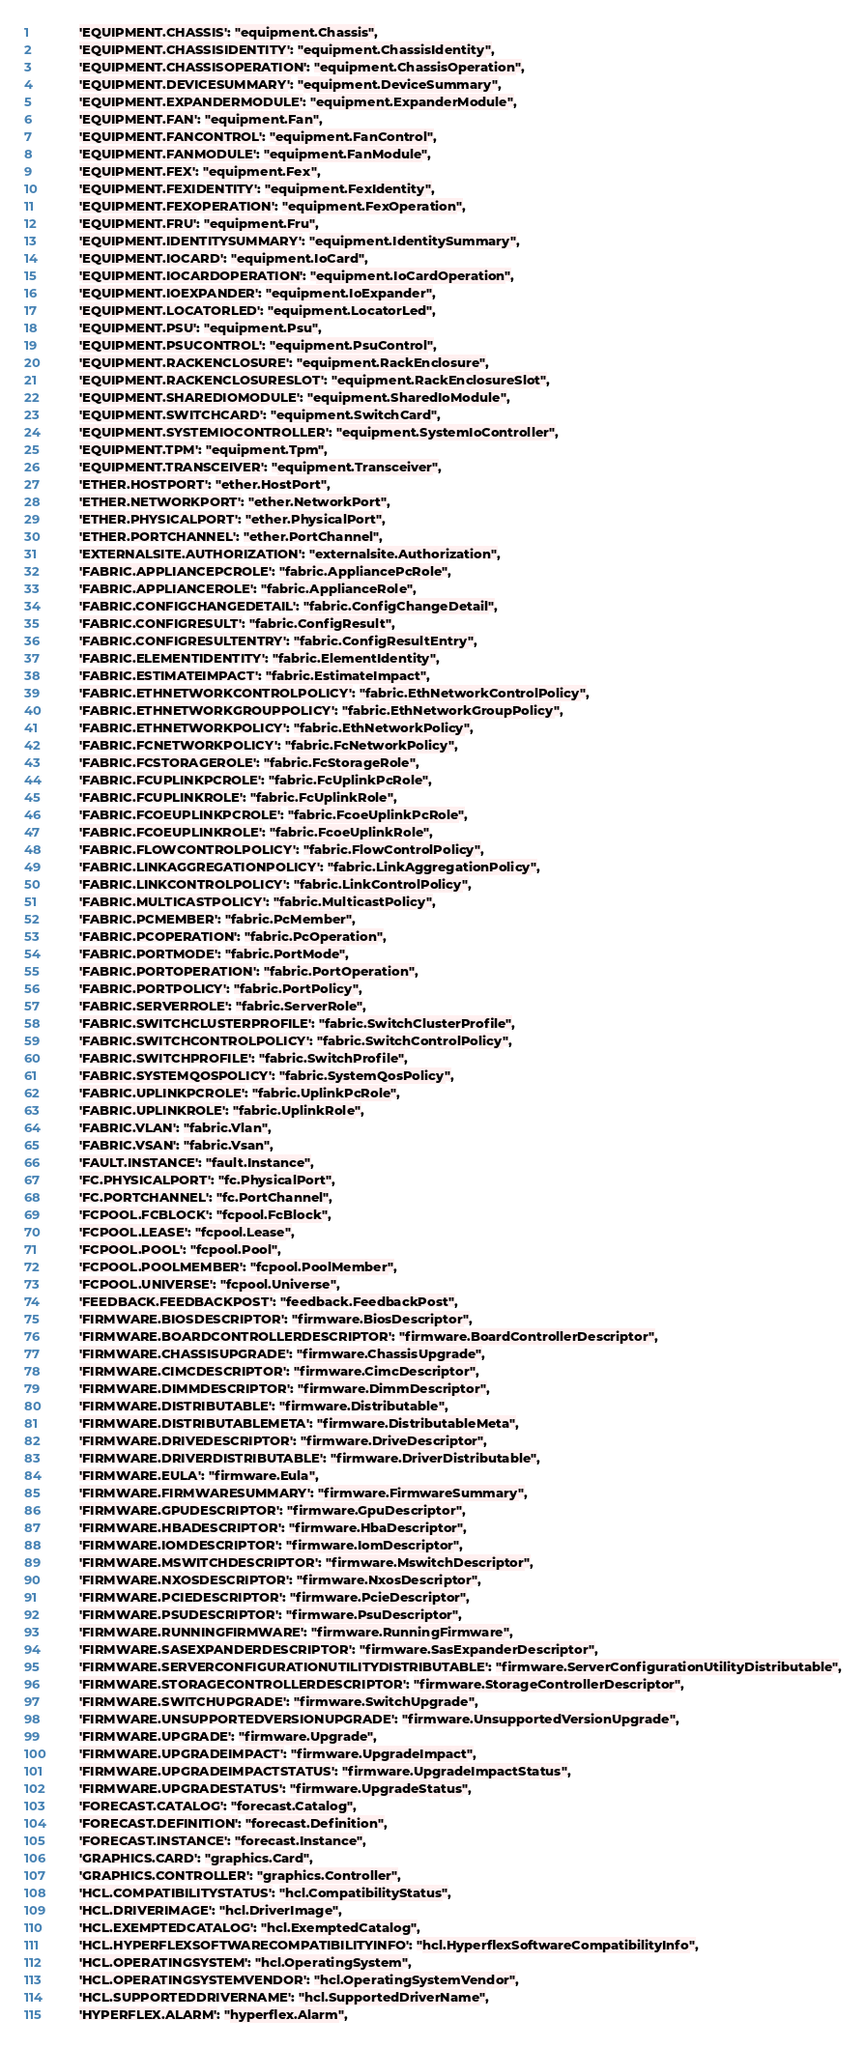Convert code to text. <code><loc_0><loc_0><loc_500><loc_500><_Python_>            'EQUIPMENT.CHASSIS': "equipment.Chassis",
            'EQUIPMENT.CHASSISIDENTITY': "equipment.ChassisIdentity",
            'EQUIPMENT.CHASSISOPERATION': "equipment.ChassisOperation",
            'EQUIPMENT.DEVICESUMMARY': "equipment.DeviceSummary",
            'EQUIPMENT.EXPANDERMODULE': "equipment.ExpanderModule",
            'EQUIPMENT.FAN': "equipment.Fan",
            'EQUIPMENT.FANCONTROL': "equipment.FanControl",
            'EQUIPMENT.FANMODULE': "equipment.FanModule",
            'EQUIPMENT.FEX': "equipment.Fex",
            'EQUIPMENT.FEXIDENTITY': "equipment.FexIdentity",
            'EQUIPMENT.FEXOPERATION': "equipment.FexOperation",
            'EQUIPMENT.FRU': "equipment.Fru",
            'EQUIPMENT.IDENTITYSUMMARY': "equipment.IdentitySummary",
            'EQUIPMENT.IOCARD': "equipment.IoCard",
            'EQUIPMENT.IOCARDOPERATION': "equipment.IoCardOperation",
            'EQUIPMENT.IOEXPANDER': "equipment.IoExpander",
            'EQUIPMENT.LOCATORLED': "equipment.LocatorLed",
            'EQUIPMENT.PSU': "equipment.Psu",
            'EQUIPMENT.PSUCONTROL': "equipment.PsuControl",
            'EQUIPMENT.RACKENCLOSURE': "equipment.RackEnclosure",
            'EQUIPMENT.RACKENCLOSURESLOT': "equipment.RackEnclosureSlot",
            'EQUIPMENT.SHAREDIOMODULE': "equipment.SharedIoModule",
            'EQUIPMENT.SWITCHCARD': "equipment.SwitchCard",
            'EQUIPMENT.SYSTEMIOCONTROLLER': "equipment.SystemIoController",
            'EQUIPMENT.TPM': "equipment.Tpm",
            'EQUIPMENT.TRANSCEIVER': "equipment.Transceiver",
            'ETHER.HOSTPORT': "ether.HostPort",
            'ETHER.NETWORKPORT': "ether.NetworkPort",
            'ETHER.PHYSICALPORT': "ether.PhysicalPort",
            'ETHER.PORTCHANNEL': "ether.PortChannel",
            'EXTERNALSITE.AUTHORIZATION': "externalsite.Authorization",
            'FABRIC.APPLIANCEPCROLE': "fabric.AppliancePcRole",
            'FABRIC.APPLIANCEROLE': "fabric.ApplianceRole",
            'FABRIC.CONFIGCHANGEDETAIL': "fabric.ConfigChangeDetail",
            'FABRIC.CONFIGRESULT': "fabric.ConfigResult",
            'FABRIC.CONFIGRESULTENTRY': "fabric.ConfigResultEntry",
            'FABRIC.ELEMENTIDENTITY': "fabric.ElementIdentity",
            'FABRIC.ESTIMATEIMPACT': "fabric.EstimateImpact",
            'FABRIC.ETHNETWORKCONTROLPOLICY': "fabric.EthNetworkControlPolicy",
            'FABRIC.ETHNETWORKGROUPPOLICY': "fabric.EthNetworkGroupPolicy",
            'FABRIC.ETHNETWORKPOLICY': "fabric.EthNetworkPolicy",
            'FABRIC.FCNETWORKPOLICY': "fabric.FcNetworkPolicy",
            'FABRIC.FCSTORAGEROLE': "fabric.FcStorageRole",
            'FABRIC.FCUPLINKPCROLE': "fabric.FcUplinkPcRole",
            'FABRIC.FCUPLINKROLE': "fabric.FcUplinkRole",
            'FABRIC.FCOEUPLINKPCROLE': "fabric.FcoeUplinkPcRole",
            'FABRIC.FCOEUPLINKROLE': "fabric.FcoeUplinkRole",
            'FABRIC.FLOWCONTROLPOLICY': "fabric.FlowControlPolicy",
            'FABRIC.LINKAGGREGATIONPOLICY': "fabric.LinkAggregationPolicy",
            'FABRIC.LINKCONTROLPOLICY': "fabric.LinkControlPolicy",
            'FABRIC.MULTICASTPOLICY': "fabric.MulticastPolicy",
            'FABRIC.PCMEMBER': "fabric.PcMember",
            'FABRIC.PCOPERATION': "fabric.PcOperation",
            'FABRIC.PORTMODE': "fabric.PortMode",
            'FABRIC.PORTOPERATION': "fabric.PortOperation",
            'FABRIC.PORTPOLICY': "fabric.PortPolicy",
            'FABRIC.SERVERROLE': "fabric.ServerRole",
            'FABRIC.SWITCHCLUSTERPROFILE': "fabric.SwitchClusterProfile",
            'FABRIC.SWITCHCONTROLPOLICY': "fabric.SwitchControlPolicy",
            'FABRIC.SWITCHPROFILE': "fabric.SwitchProfile",
            'FABRIC.SYSTEMQOSPOLICY': "fabric.SystemQosPolicy",
            'FABRIC.UPLINKPCROLE': "fabric.UplinkPcRole",
            'FABRIC.UPLINKROLE': "fabric.UplinkRole",
            'FABRIC.VLAN': "fabric.Vlan",
            'FABRIC.VSAN': "fabric.Vsan",
            'FAULT.INSTANCE': "fault.Instance",
            'FC.PHYSICALPORT': "fc.PhysicalPort",
            'FC.PORTCHANNEL': "fc.PortChannel",
            'FCPOOL.FCBLOCK': "fcpool.FcBlock",
            'FCPOOL.LEASE': "fcpool.Lease",
            'FCPOOL.POOL': "fcpool.Pool",
            'FCPOOL.POOLMEMBER': "fcpool.PoolMember",
            'FCPOOL.UNIVERSE': "fcpool.Universe",
            'FEEDBACK.FEEDBACKPOST': "feedback.FeedbackPost",
            'FIRMWARE.BIOSDESCRIPTOR': "firmware.BiosDescriptor",
            'FIRMWARE.BOARDCONTROLLERDESCRIPTOR': "firmware.BoardControllerDescriptor",
            'FIRMWARE.CHASSISUPGRADE': "firmware.ChassisUpgrade",
            'FIRMWARE.CIMCDESCRIPTOR': "firmware.CimcDescriptor",
            'FIRMWARE.DIMMDESCRIPTOR': "firmware.DimmDescriptor",
            'FIRMWARE.DISTRIBUTABLE': "firmware.Distributable",
            'FIRMWARE.DISTRIBUTABLEMETA': "firmware.DistributableMeta",
            'FIRMWARE.DRIVEDESCRIPTOR': "firmware.DriveDescriptor",
            'FIRMWARE.DRIVERDISTRIBUTABLE': "firmware.DriverDistributable",
            'FIRMWARE.EULA': "firmware.Eula",
            'FIRMWARE.FIRMWARESUMMARY': "firmware.FirmwareSummary",
            'FIRMWARE.GPUDESCRIPTOR': "firmware.GpuDescriptor",
            'FIRMWARE.HBADESCRIPTOR': "firmware.HbaDescriptor",
            'FIRMWARE.IOMDESCRIPTOR': "firmware.IomDescriptor",
            'FIRMWARE.MSWITCHDESCRIPTOR': "firmware.MswitchDescriptor",
            'FIRMWARE.NXOSDESCRIPTOR': "firmware.NxosDescriptor",
            'FIRMWARE.PCIEDESCRIPTOR': "firmware.PcieDescriptor",
            'FIRMWARE.PSUDESCRIPTOR': "firmware.PsuDescriptor",
            'FIRMWARE.RUNNINGFIRMWARE': "firmware.RunningFirmware",
            'FIRMWARE.SASEXPANDERDESCRIPTOR': "firmware.SasExpanderDescriptor",
            'FIRMWARE.SERVERCONFIGURATIONUTILITYDISTRIBUTABLE': "firmware.ServerConfigurationUtilityDistributable",
            'FIRMWARE.STORAGECONTROLLERDESCRIPTOR': "firmware.StorageControllerDescriptor",
            'FIRMWARE.SWITCHUPGRADE': "firmware.SwitchUpgrade",
            'FIRMWARE.UNSUPPORTEDVERSIONUPGRADE': "firmware.UnsupportedVersionUpgrade",
            'FIRMWARE.UPGRADE': "firmware.Upgrade",
            'FIRMWARE.UPGRADEIMPACT': "firmware.UpgradeImpact",
            'FIRMWARE.UPGRADEIMPACTSTATUS': "firmware.UpgradeImpactStatus",
            'FIRMWARE.UPGRADESTATUS': "firmware.UpgradeStatus",
            'FORECAST.CATALOG': "forecast.Catalog",
            'FORECAST.DEFINITION': "forecast.Definition",
            'FORECAST.INSTANCE': "forecast.Instance",
            'GRAPHICS.CARD': "graphics.Card",
            'GRAPHICS.CONTROLLER': "graphics.Controller",
            'HCL.COMPATIBILITYSTATUS': "hcl.CompatibilityStatus",
            'HCL.DRIVERIMAGE': "hcl.DriverImage",
            'HCL.EXEMPTEDCATALOG': "hcl.ExemptedCatalog",
            'HCL.HYPERFLEXSOFTWARECOMPATIBILITYINFO': "hcl.HyperflexSoftwareCompatibilityInfo",
            'HCL.OPERATINGSYSTEM': "hcl.OperatingSystem",
            'HCL.OPERATINGSYSTEMVENDOR': "hcl.OperatingSystemVendor",
            'HCL.SUPPORTEDDRIVERNAME': "hcl.SupportedDriverName",
            'HYPERFLEX.ALARM': "hyperflex.Alarm",</code> 